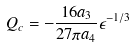Convert formula to latex. <formula><loc_0><loc_0><loc_500><loc_500>Q _ { c } = - \frac { 1 6 a _ { 3 } } { 2 7 \pi a _ { 4 } } \epsilon ^ { - 1 / 3 }</formula> 